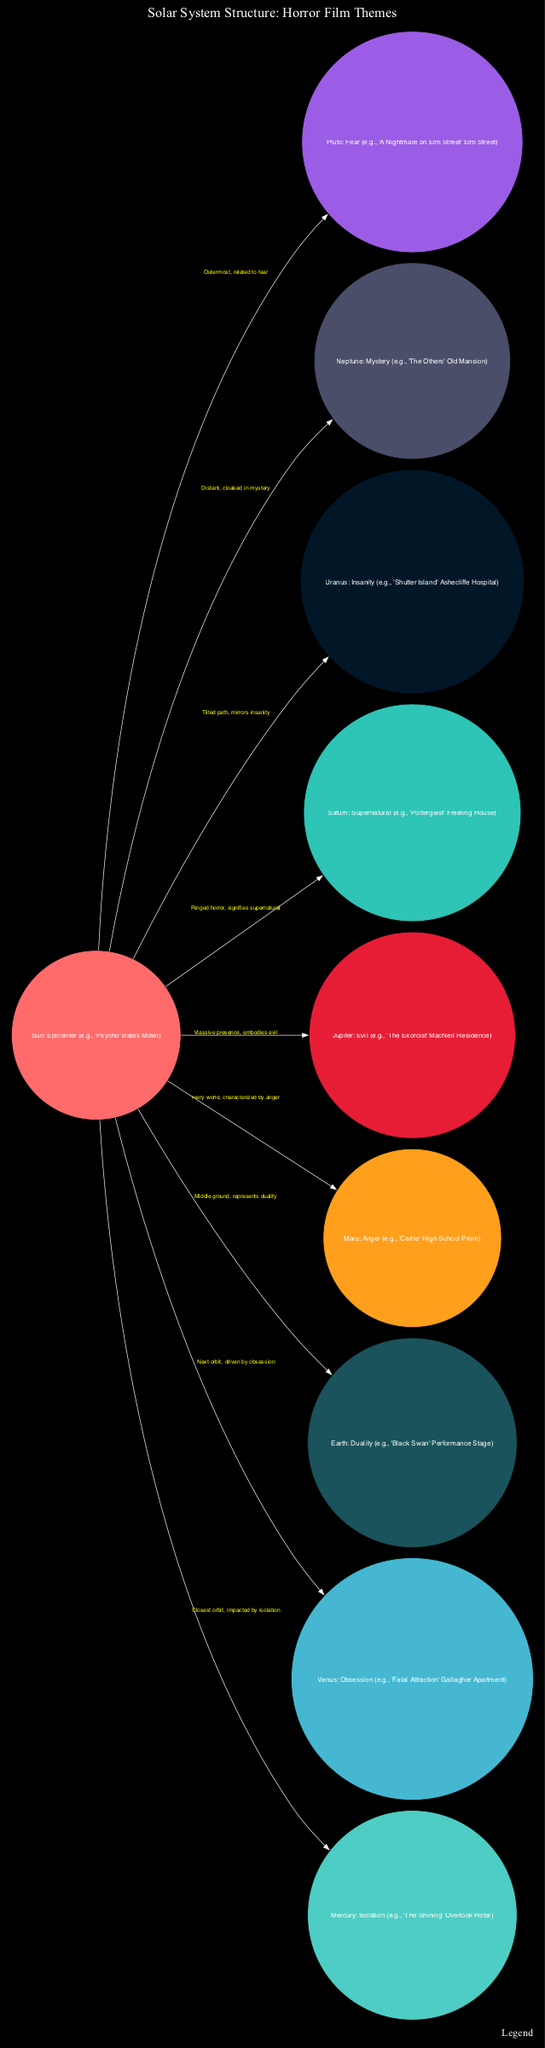What is the central theme represented by the Sun in the diagram? The Sun is labeled as "Bates Motel (Epicenter)", indicating that it serves as the central and most significant reference point in the diagram, similar to the central theme of fear and horror in the film "Psycho."
Answer: Bates Motel (Epicenter) Which horror film theme is represented by Jupiter? The diagram shows Jupiter associated with "Evil," referencing the themes showcased in "The Exorcist" through the "MacNeil Residence." This is clearly labeled in the respective section of the diagram.
Answer: Evil How many planets are represented in the diagram? By counting the nodes in the diagram, we find that there are a total of 10 planets represented, corresponding to the usual celestial bodies in our solar system.
Answer: 10 What symbolic emotion is associated with Mars? The diagram indicates that Mars is linked to "Anger," referring to the iconic high school prom scene from "Carrie," which embodies the theme of rage and chaos.
Answer: Anger Which planet is associated with themes of obsession? Venus is explicitly labeled as representing "Obsession," correlated with the setting of "Fatal Attraction" in the Gallagher Apartment, according to the legend provided in the diagram.
Answer: Obsession What does the edge labeled "Closest orbit, impacted by isolation" connect? The edge connects the Sun to Mercury, indicating that Mercury is the closest planet to the Sun and representing the theme of isolation, which is emphasized by its connection to the "Overlook Hotel" from "The Shining."
Answer: Sun to Mercury Which horror film element does Neptune symbolize? The diagram connects Neptune with "Mystery," linking it to themes generated in "The Others," depicted through the "Old Mansion." This reflects the mysterious aspects associated with Neptune in the context of the diagram.
Answer: Mystery What is the relationship indicated by the edge from the Sun to Saturn? The edge from the Sun to Saturn signifies the supernatural element, represented as "Ringed horror, signifies supernatural," which demonstrates how Saturn encapsulates the eerie and otherworldly themes, as seen in "Poltergeist."
Answer: Supernatural What planet serves as the outermost celestial body associated with fear? Pluto is identified as the outermost planet in the diagram, and it is associated with "Fear," drawing references from "A Nightmare on Elm Street," hinting at its secluded and chilling presence.
Answer: Pluto 